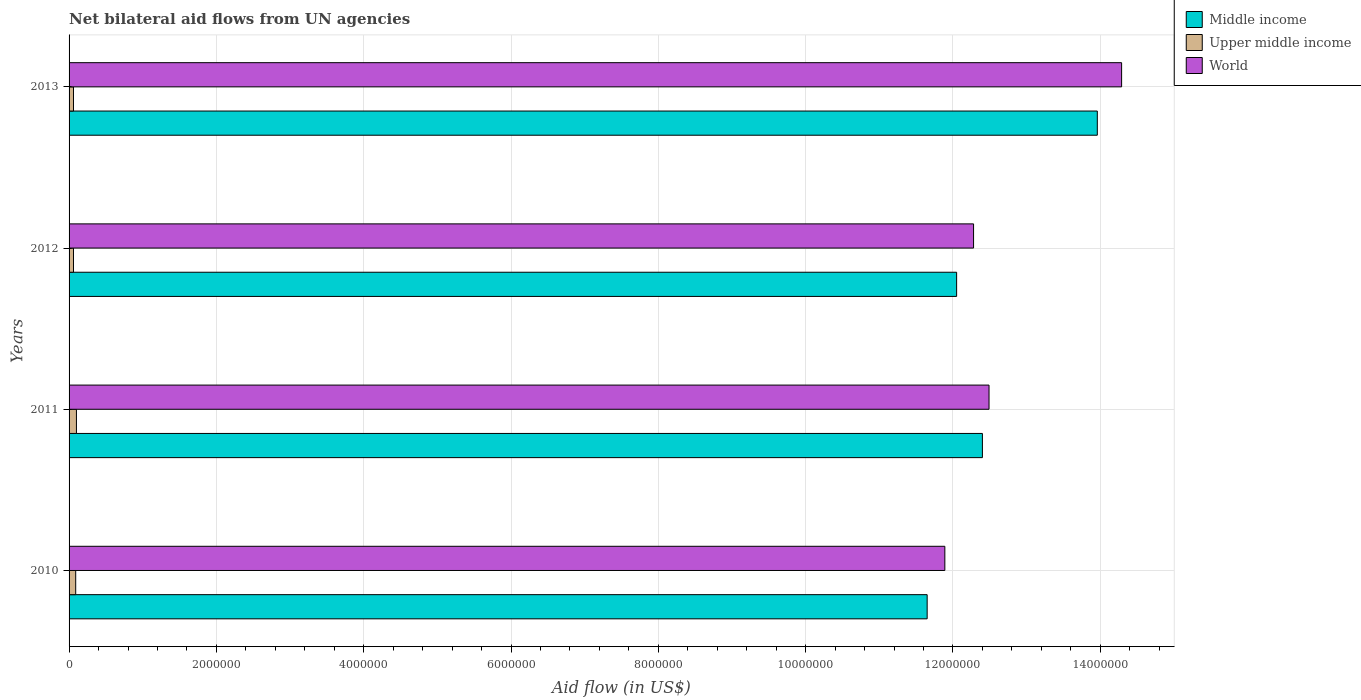Are the number of bars per tick equal to the number of legend labels?
Provide a succinct answer. Yes. How many bars are there on the 3rd tick from the bottom?
Provide a short and direct response. 3. What is the label of the 4th group of bars from the top?
Your answer should be very brief. 2010. In how many cases, is the number of bars for a given year not equal to the number of legend labels?
Provide a succinct answer. 0. What is the net bilateral aid flow in Upper middle income in 2012?
Give a very brief answer. 6.00e+04. Across all years, what is the maximum net bilateral aid flow in Middle income?
Make the answer very short. 1.40e+07. Across all years, what is the minimum net bilateral aid flow in Middle income?
Keep it short and to the point. 1.16e+07. In which year was the net bilateral aid flow in World minimum?
Your answer should be very brief. 2010. What is the total net bilateral aid flow in Middle income in the graph?
Your answer should be very brief. 5.01e+07. What is the difference between the net bilateral aid flow in Upper middle income in 2010 and that in 2011?
Keep it short and to the point. -10000. What is the difference between the net bilateral aid flow in Upper middle income in 2010 and the net bilateral aid flow in Middle income in 2012?
Provide a succinct answer. -1.20e+07. What is the average net bilateral aid flow in World per year?
Provide a succinct answer. 1.27e+07. In the year 2010, what is the difference between the net bilateral aid flow in Middle income and net bilateral aid flow in Upper middle income?
Provide a succinct answer. 1.16e+07. Is the net bilateral aid flow in Upper middle income in 2010 less than that in 2013?
Offer a terse response. No. Is the difference between the net bilateral aid flow in Middle income in 2010 and 2011 greater than the difference between the net bilateral aid flow in Upper middle income in 2010 and 2011?
Make the answer very short. No. What is the difference between the highest and the second highest net bilateral aid flow in World?
Keep it short and to the point. 1.80e+06. What is the difference between the highest and the lowest net bilateral aid flow in Upper middle income?
Offer a terse response. 4.00e+04. In how many years, is the net bilateral aid flow in Upper middle income greater than the average net bilateral aid flow in Upper middle income taken over all years?
Your answer should be compact. 2. What does the 3rd bar from the top in 2013 represents?
Offer a terse response. Middle income. What does the 2nd bar from the bottom in 2013 represents?
Ensure brevity in your answer.  Upper middle income. Is it the case that in every year, the sum of the net bilateral aid flow in World and net bilateral aid flow in Upper middle income is greater than the net bilateral aid flow in Middle income?
Offer a terse response. Yes. Are all the bars in the graph horizontal?
Your answer should be very brief. Yes. What is the difference between two consecutive major ticks on the X-axis?
Ensure brevity in your answer.  2.00e+06. Are the values on the major ticks of X-axis written in scientific E-notation?
Provide a short and direct response. No. Does the graph contain any zero values?
Your answer should be very brief. No. Does the graph contain grids?
Offer a terse response. Yes. How are the legend labels stacked?
Make the answer very short. Vertical. What is the title of the graph?
Offer a terse response. Net bilateral aid flows from UN agencies. Does "Malawi" appear as one of the legend labels in the graph?
Your answer should be very brief. No. What is the label or title of the X-axis?
Provide a succinct answer. Aid flow (in US$). What is the label or title of the Y-axis?
Your answer should be very brief. Years. What is the Aid flow (in US$) in Middle income in 2010?
Make the answer very short. 1.16e+07. What is the Aid flow (in US$) in Upper middle income in 2010?
Provide a short and direct response. 9.00e+04. What is the Aid flow (in US$) in World in 2010?
Keep it short and to the point. 1.19e+07. What is the Aid flow (in US$) of Middle income in 2011?
Provide a short and direct response. 1.24e+07. What is the Aid flow (in US$) in World in 2011?
Your answer should be very brief. 1.25e+07. What is the Aid flow (in US$) in Middle income in 2012?
Ensure brevity in your answer.  1.20e+07. What is the Aid flow (in US$) in Upper middle income in 2012?
Your answer should be compact. 6.00e+04. What is the Aid flow (in US$) in World in 2012?
Offer a terse response. 1.23e+07. What is the Aid flow (in US$) of Middle income in 2013?
Your answer should be compact. 1.40e+07. What is the Aid flow (in US$) in Upper middle income in 2013?
Ensure brevity in your answer.  6.00e+04. What is the Aid flow (in US$) in World in 2013?
Offer a very short reply. 1.43e+07. Across all years, what is the maximum Aid flow (in US$) in Middle income?
Provide a short and direct response. 1.40e+07. Across all years, what is the maximum Aid flow (in US$) of World?
Offer a terse response. 1.43e+07. Across all years, what is the minimum Aid flow (in US$) in Middle income?
Make the answer very short. 1.16e+07. Across all years, what is the minimum Aid flow (in US$) of World?
Provide a short and direct response. 1.19e+07. What is the total Aid flow (in US$) of Middle income in the graph?
Give a very brief answer. 5.01e+07. What is the total Aid flow (in US$) of Upper middle income in the graph?
Keep it short and to the point. 3.10e+05. What is the total Aid flow (in US$) of World in the graph?
Provide a succinct answer. 5.10e+07. What is the difference between the Aid flow (in US$) of Middle income in 2010 and that in 2011?
Make the answer very short. -7.50e+05. What is the difference between the Aid flow (in US$) of World in 2010 and that in 2011?
Ensure brevity in your answer.  -6.00e+05. What is the difference between the Aid flow (in US$) in Middle income in 2010 and that in 2012?
Your response must be concise. -4.00e+05. What is the difference between the Aid flow (in US$) in World in 2010 and that in 2012?
Your response must be concise. -3.90e+05. What is the difference between the Aid flow (in US$) in Middle income in 2010 and that in 2013?
Offer a terse response. -2.31e+06. What is the difference between the Aid flow (in US$) in Upper middle income in 2010 and that in 2013?
Your answer should be very brief. 3.00e+04. What is the difference between the Aid flow (in US$) of World in 2010 and that in 2013?
Ensure brevity in your answer.  -2.40e+06. What is the difference between the Aid flow (in US$) of Middle income in 2011 and that in 2012?
Provide a short and direct response. 3.50e+05. What is the difference between the Aid flow (in US$) in Middle income in 2011 and that in 2013?
Your answer should be very brief. -1.56e+06. What is the difference between the Aid flow (in US$) of Upper middle income in 2011 and that in 2013?
Give a very brief answer. 4.00e+04. What is the difference between the Aid flow (in US$) in World in 2011 and that in 2013?
Ensure brevity in your answer.  -1.80e+06. What is the difference between the Aid flow (in US$) in Middle income in 2012 and that in 2013?
Your response must be concise. -1.91e+06. What is the difference between the Aid flow (in US$) of World in 2012 and that in 2013?
Make the answer very short. -2.01e+06. What is the difference between the Aid flow (in US$) of Middle income in 2010 and the Aid flow (in US$) of Upper middle income in 2011?
Offer a very short reply. 1.16e+07. What is the difference between the Aid flow (in US$) in Middle income in 2010 and the Aid flow (in US$) in World in 2011?
Offer a very short reply. -8.40e+05. What is the difference between the Aid flow (in US$) of Upper middle income in 2010 and the Aid flow (in US$) of World in 2011?
Provide a short and direct response. -1.24e+07. What is the difference between the Aid flow (in US$) in Middle income in 2010 and the Aid flow (in US$) in Upper middle income in 2012?
Provide a succinct answer. 1.16e+07. What is the difference between the Aid flow (in US$) in Middle income in 2010 and the Aid flow (in US$) in World in 2012?
Give a very brief answer. -6.30e+05. What is the difference between the Aid flow (in US$) in Upper middle income in 2010 and the Aid flow (in US$) in World in 2012?
Give a very brief answer. -1.22e+07. What is the difference between the Aid flow (in US$) of Middle income in 2010 and the Aid flow (in US$) of Upper middle income in 2013?
Ensure brevity in your answer.  1.16e+07. What is the difference between the Aid flow (in US$) of Middle income in 2010 and the Aid flow (in US$) of World in 2013?
Provide a short and direct response. -2.64e+06. What is the difference between the Aid flow (in US$) in Upper middle income in 2010 and the Aid flow (in US$) in World in 2013?
Offer a terse response. -1.42e+07. What is the difference between the Aid flow (in US$) of Middle income in 2011 and the Aid flow (in US$) of Upper middle income in 2012?
Offer a terse response. 1.23e+07. What is the difference between the Aid flow (in US$) in Upper middle income in 2011 and the Aid flow (in US$) in World in 2012?
Offer a terse response. -1.22e+07. What is the difference between the Aid flow (in US$) of Middle income in 2011 and the Aid flow (in US$) of Upper middle income in 2013?
Keep it short and to the point. 1.23e+07. What is the difference between the Aid flow (in US$) of Middle income in 2011 and the Aid flow (in US$) of World in 2013?
Your answer should be compact. -1.89e+06. What is the difference between the Aid flow (in US$) of Upper middle income in 2011 and the Aid flow (in US$) of World in 2013?
Offer a very short reply. -1.42e+07. What is the difference between the Aid flow (in US$) in Middle income in 2012 and the Aid flow (in US$) in Upper middle income in 2013?
Provide a succinct answer. 1.20e+07. What is the difference between the Aid flow (in US$) in Middle income in 2012 and the Aid flow (in US$) in World in 2013?
Offer a terse response. -2.24e+06. What is the difference between the Aid flow (in US$) in Upper middle income in 2012 and the Aid flow (in US$) in World in 2013?
Keep it short and to the point. -1.42e+07. What is the average Aid flow (in US$) in Middle income per year?
Make the answer very short. 1.25e+07. What is the average Aid flow (in US$) in Upper middle income per year?
Keep it short and to the point. 7.75e+04. What is the average Aid flow (in US$) of World per year?
Ensure brevity in your answer.  1.27e+07. In the year 2010, what is the difference between the Aid flow (in US$) of Middle income and Aid flow (in US$) of Upper middle income?
Offer a terse response. 1.16e+07. In the year 2010, what is the difference between the Aid flow (in US$) in Middle income and Aid flow (in US$) in World?
Make the answer very short. -2.40e+05. In the year 2010, what is the difference between the Aid flow (in US$) in Upper middle income and Aid flow (in US$) in World?
Provide a succinct answer. -1.18e+07. In the year 2011, what is the difference between the Aid flow (in US$) in Middle income and Aid flow (in US$) in Upper middle income?
Your answer should be very brief. 1.23e+07. In the year 2011, what is the difference between the Aid flow (in US$) of Upper middle income and Aid flow (in US$) of World?
Offer a very short reply. -1.24e+07. In the year 2012, what is the difference between the Aid flow (in US$) in Middle income and Aid flow (in US$) in Upper middle income?
Ensure brevity in your answer.  1.20e+07. In the year 2012, what is the difference between the Aid flow (in US$) of Upper middle income and Aid flow (in US$) of World?
Keep it short and to the point. -1.22e+07. In the year 2013, what is the difference between the Aid flow (in US$) in Middle income and Aid flow (in US$) in Upper middle income?
Your response must be concise. 1.39e+07. In the year 2013, what is the difference between the Aid flow (in US$) in Middle income and Aid flow (in US$) in World?
Your response must be concise. -3.30e+05. In the year 2013, what is the difference between the Aid flow (in US$) of Upper middle income and Aid flow (in US$) of World?
Keep it short and to the point. -1.42e+07. What is the ratio of the Aid flow (in US$) in Middle income in 2010 to that in 2011?
Provide a short and direct response. 0.94. What is the ratio of the Aid flow (in US$) in Middle income in 2010 to that in 2012?
Your answer should be very brief. 0.97. What is the ratio of the Aid flow (in US$) in Upper middle income in 2010 to that in 2012?
Offer a terse response. 1.5. What is the ratio of the Aid flow (in US$) in World in 2010 to that in 2012?
Your response must be concise. 0.97. What is the ratio of the Aid flow (in US$) in Middle income in 2010 to that in 2013?
Your answer should be very brief. 0.83. What is the ratio of the Aid flow (in US$) of World in 2010 to that in 2013?
Give a very brief answer. 0.83. What is the ratio of the Aid flow (in US$) of Upper middle income in 2011 to that in 2012?
Ensure brevity in your answer.  1.67. What is the ratio of the Aid flow (in US$) of World in 2011 to that in 2012?
Make the answer very short. 1.02. What is the ratio of the Aid flow (in US$) of Middle income in 2011 to that in 2013?
Offer a terse response. 0.89. What is the ratio of the Aid flow (in US$) of World in 2011 to that in 2013?
Offer a very short reply. 0.87. What is the ratio of the Aid flow (in US$) of Middle income in 2012 to that in 2013?
Provide a succinct answer. 0.86. What is the ratio of the Aid flow (in US$) in World in 2012 to that in 2013?
Your response must be concise. 0.86. What is the difference between the highest and the second highest Aid flow (in US$) of Middle income?
Give a very brief answer. 1.56e+06. What is the difference between the highest and the second highest Aid flow (in US$) of World?
Ensure brevity in your answer.  1.80e+06. What is the difference between the highest and the lowest Aid flow (in US$) of Middle income?
Ensure brevity in your answer.  2.31e+06. What is the difference between the highest and the lowest Aid flow (in US$) of Upper middle income?
Offer a very short reply. 4.00e+04. What is the difference between the highest and the lowest Aid flow (in US$) of World?
Provide a short and direct response. 2.40e+06. 